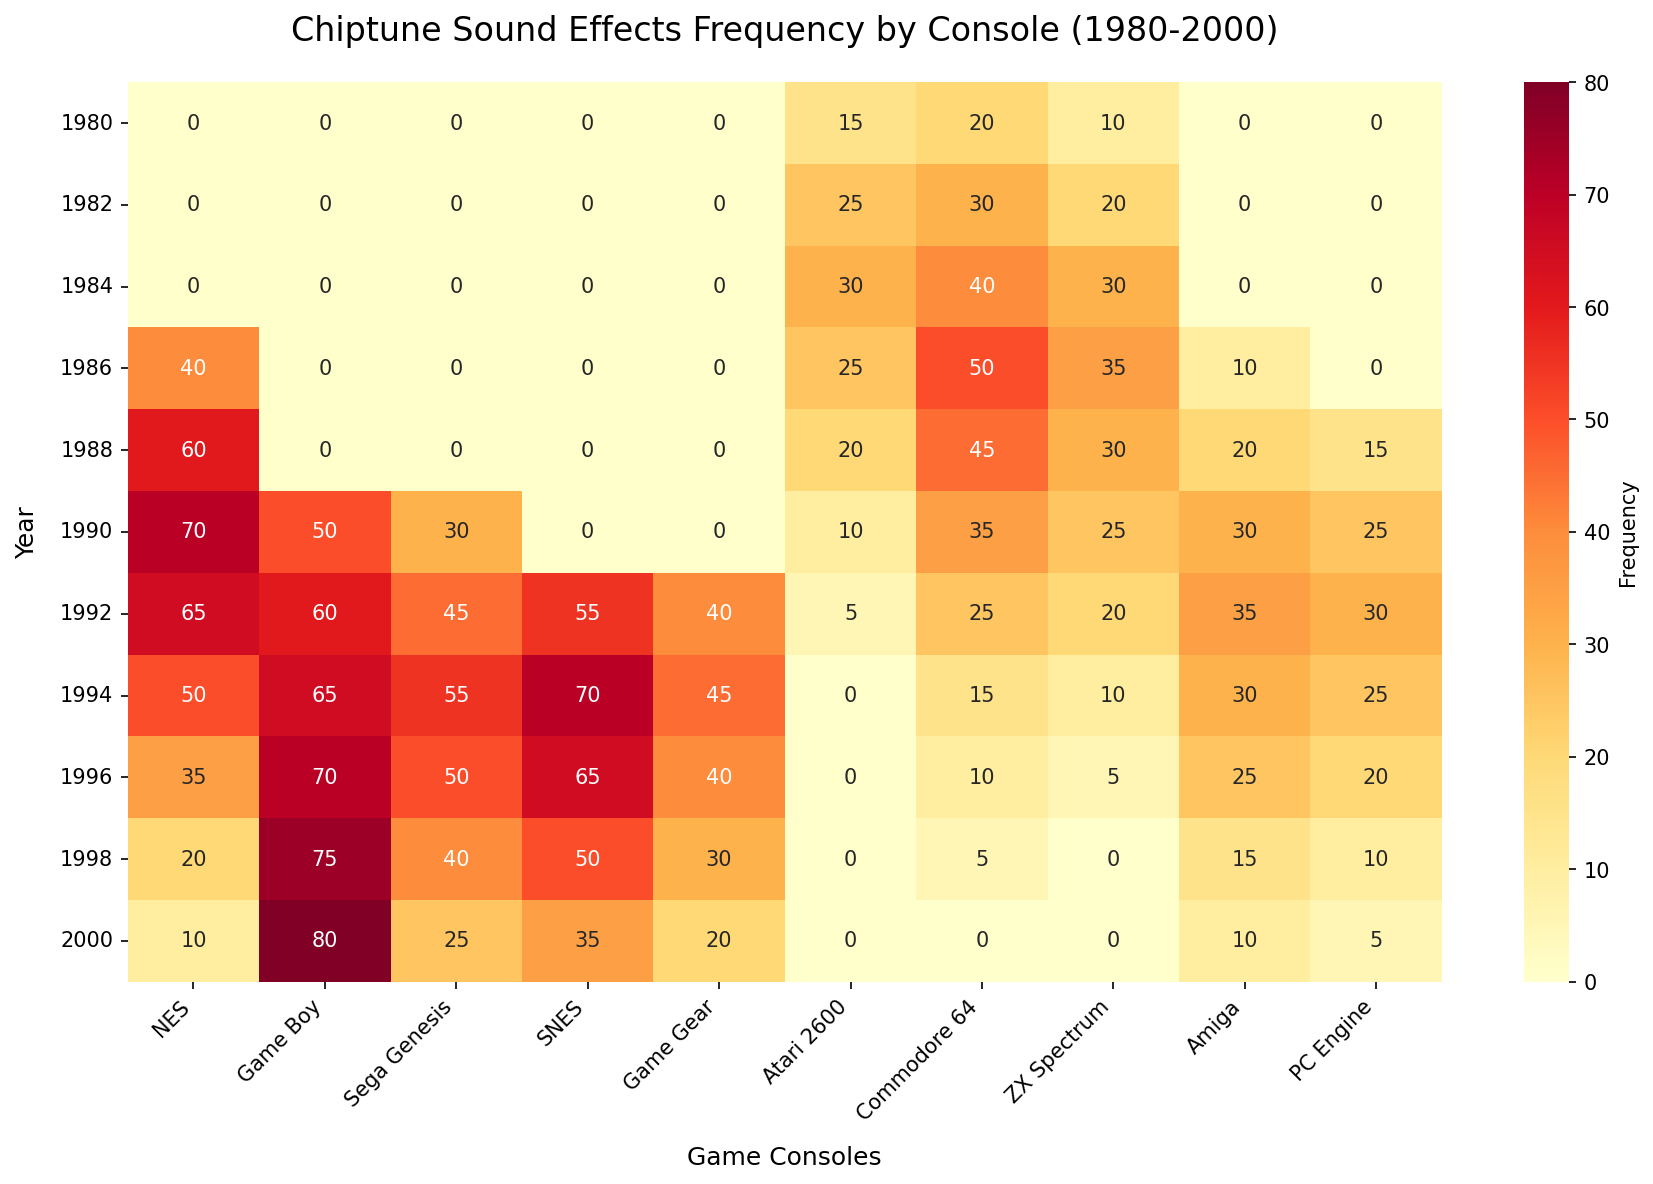What year did the NES have the highest frequency of chiptune sound effects? First, identify the column for NES. Then scan down the NES column to find the highest value. The highest value for NES is 70, which occurred in 1990.
Answer: 1990 In which year do the majority of consoles show a significant increase in frequency from the previous years? Look at where multiple consoles have higher frequency values compared to previous years. The year 1990 sees significant increases for the NES, Game Boy, Commodore 64, and ZX Spectrum compared to 1988.
Answer: 1990 Which console has the most consistent frequency distribution over the years? Review the values for each console across all years to see which has the least fluctuation. The Game Boy shows a relatively consistent increasing trend from 1990 to 2000.
Answer: Game Boy In which year did the SNES first appear with chiptune sound effects, and what was its frequency? Look for the first non-zero value in the SNES column. The SNES first appears in 1992 with a frequency of 55.
Answer: 1992, 55 Compare the frequency of chiptune sound effects on the Commodore 64 in 1984 and 1992. Find the values for 1984 and 1992 in the Commodore 64 column. In 1984, the frequency is 40, and in 1992, it is 25.
Answer: 1984: 40, 1992: 25 Which console had the highest frequency of chiptune sound effects in 1998, and what was the value? Look at the frequency values for all consoles in 1998. The Game Boy has the highest frequency with a value of 75.
Answer: Game Boy, 75 Between 1988 and 1992, which console saw the largest increase in chiptune sound effects frequency? Calculate the difference between the 1992 and 1988 values for all consoles. The Game Boy increased from 0 in 1988 to 60 in 1992, which is the largest increase.
Answer: Game Boy What is the sum of chiptune sound effects frequencies for NES and SNES in 1994? Add the frequencies of NES and SNES in 1994: 50 (NES) + 70 (SNES) = 120.
Answer: 120 In which year was the Amiga's chiptune sound effects frequency the highest? Scan the Amiga column for the maximum value to identify the year. The highest frequency for Amiga is 35 in 1992.
Answer: 1992 What is the average frequency of chiptune sound effects on the Atari 2600 across all years? Add the values for the Atari 2600 and divide by the number of years. (15 + 25 + 30 + 25 + 20 + 10 + 5 + 0 + 0 + 0 + 0)/11 = 12.73.
Answer: 12.73 